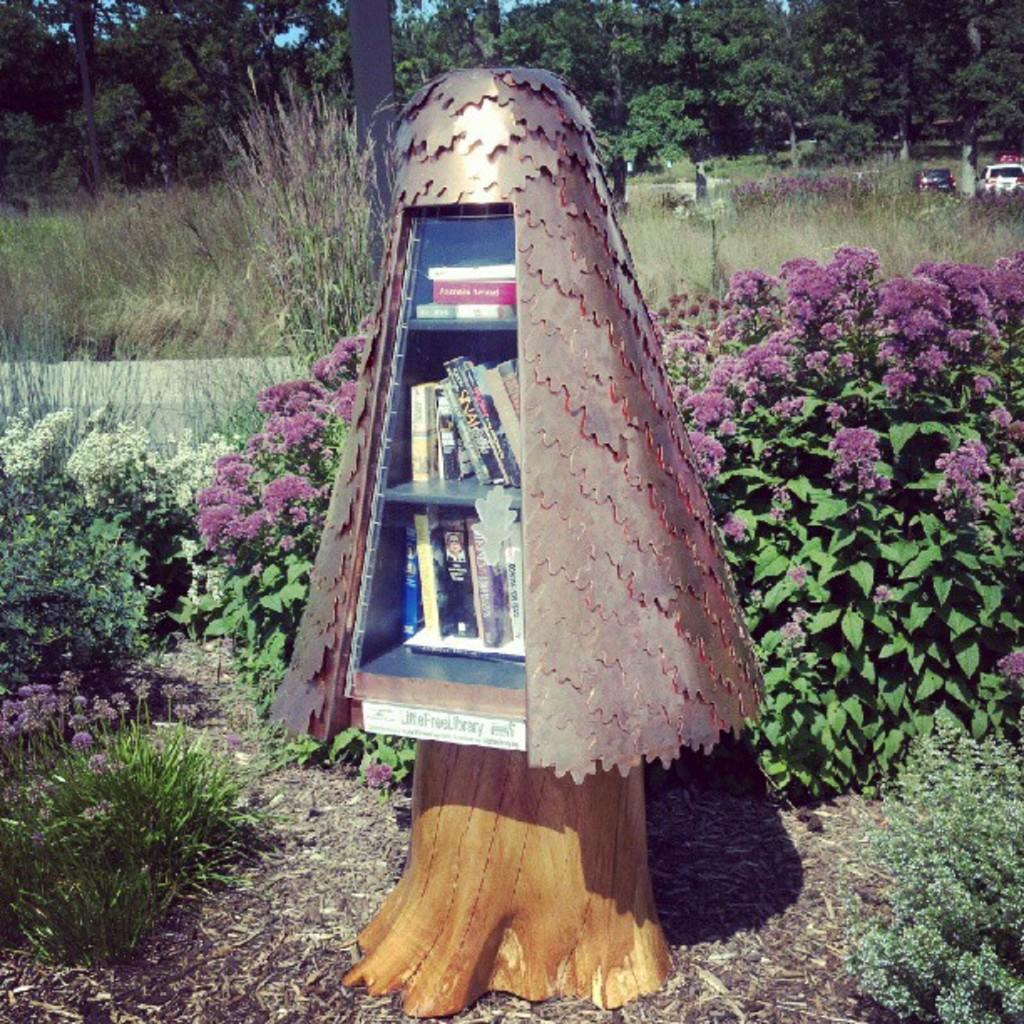What is the main object in the center of the image? There is a cupboard in the center of the image. What feature does the cupboard have? The cupboard has shelves. What can be found inside the cupboard? There are books inside the cupboard. What type of vegetation is present in the image? There are plants with flowers in the image. What are the tall, thin structures in the image? There are poles in the image. What is visible in the background of the image? There is a group of trees and the sky in the image. What is the current tax rate for the books inside the cupboard? There is no information about tax rates in the image, as it focuses on the objects and elements present. 